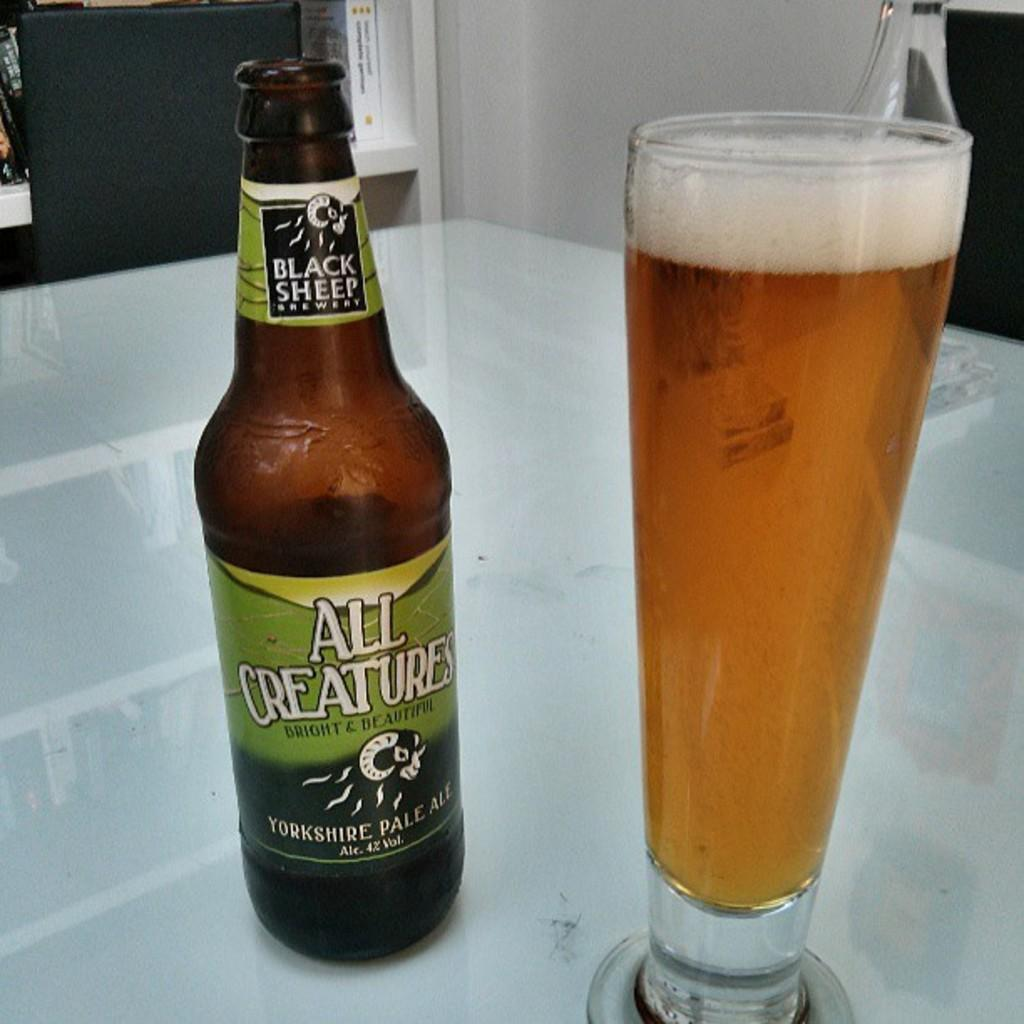<image>
Present a compact description of the photo's key features. The beer bottle shown is from the black sheep brewery. 